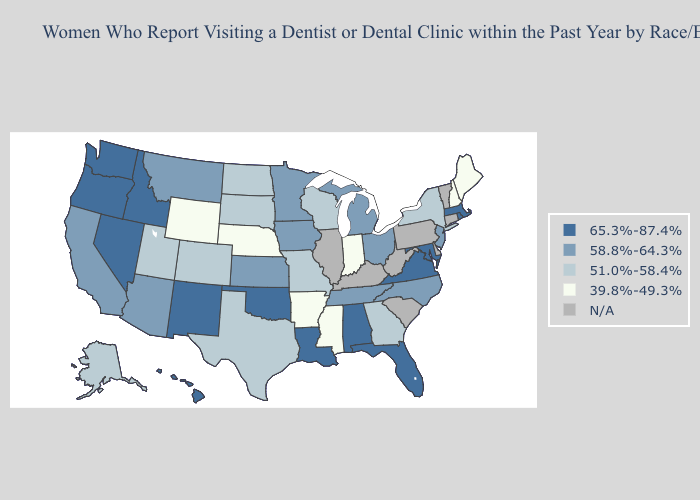Which states hav the highest value in the South?
Answer briefly. Alabama, Florida, Louisiana, Maryland, Oklahoma, Virginia. What is the lowest value in the Northeast?
Keep it brief. 39.8%-49.3%. Does Georgia have the highest value in the South?
Keep it brief. No. What is the highest value in the USA?
Answer briefly. 65.3%-87.4%. What is the value of Maryland?
Short answer required. 65.3%-87.4%. Among the states that border Massachusetts , which have the lowest value?
Keep it brief. New Hampshire. Does Montana have the lowest value in the West?
Short answer required. No. Which states have the lowest value in the West?
Concise answer only. Wyoming. Name the states that have a value in the range 51.0%-58.4%?
Concise answer only. Alaska, Colorado, Georgia, Missouri, New York, North Dakota, South Dakota, Texas, Utah, Wisconsin. Does the first symbol in the legend represent the smallest category?
Short answer required. No. Name the states that have a value in the range N/A?
Keep it brief. Connecticut, Delaware, Illinois, Kentucky, Pennsylvania, South Carolina, Vermont, West Virginia. Name the states that have a value in the range 58.8%-64.3%?
Keep it brief. Arizona, California, Iowa, Kansas, Michigan, Minnesota, Montana, New Jersey, North Carolina, Ohio, Tennessee. Is the legend a continuous bar?
Concise answer only. No. Does Mississippi have the lowest value in the USA?
Short answer required. Yes. Name the states that have a value in the range 51.0%-58.4%?
Quick response, please. Alaska, Colorado, Georgia, Missouri, New York, North Dakota, South Dakota, Texas, Utah, Wisconsin. 